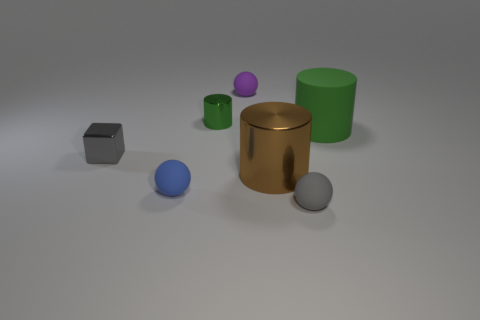There is a tiny shiny object that is on the left side of the tiny matte object left of the small green object that is behind the big matte object; what is its color?
Keep it short and to the point. Gray. The other green object that is the same shape as the small green object is what size?
Your answer should be very brief. Large. Are there fewer gray things in front of the large rubber cylinder than brown things that are behind the small green object?
Make the answer very short. No. What is the shape of the object that is both to the right of the purple matte object and behind the tiny gray metallic object?
Provide a succinct answer. Cylinder. There is a green thing that is the same material as the big brown object; what size is it?
Provide a short and direct response. Small. Do the tiny metallic cylinder and the big object behind the tiny gray cube have the same color?
Provide a short and direct response. Yes. There is a sphere that is both on the left side of the tiny gray ball and to the right of the blue rubber ball; what material is it?
Provide a short and direct response. Rubber. There is a shiny object that is the same color as the large matte thing; what size is it?
Your answer should be very brief. Small. Do the tiny gray thing that is behind the big brown cylinder and the small metallic object that is behind the big matte thing have the same shape?
Provide a succinct answer. No. Is there a big brown metallic object?
Your response must be concise. Yes. 